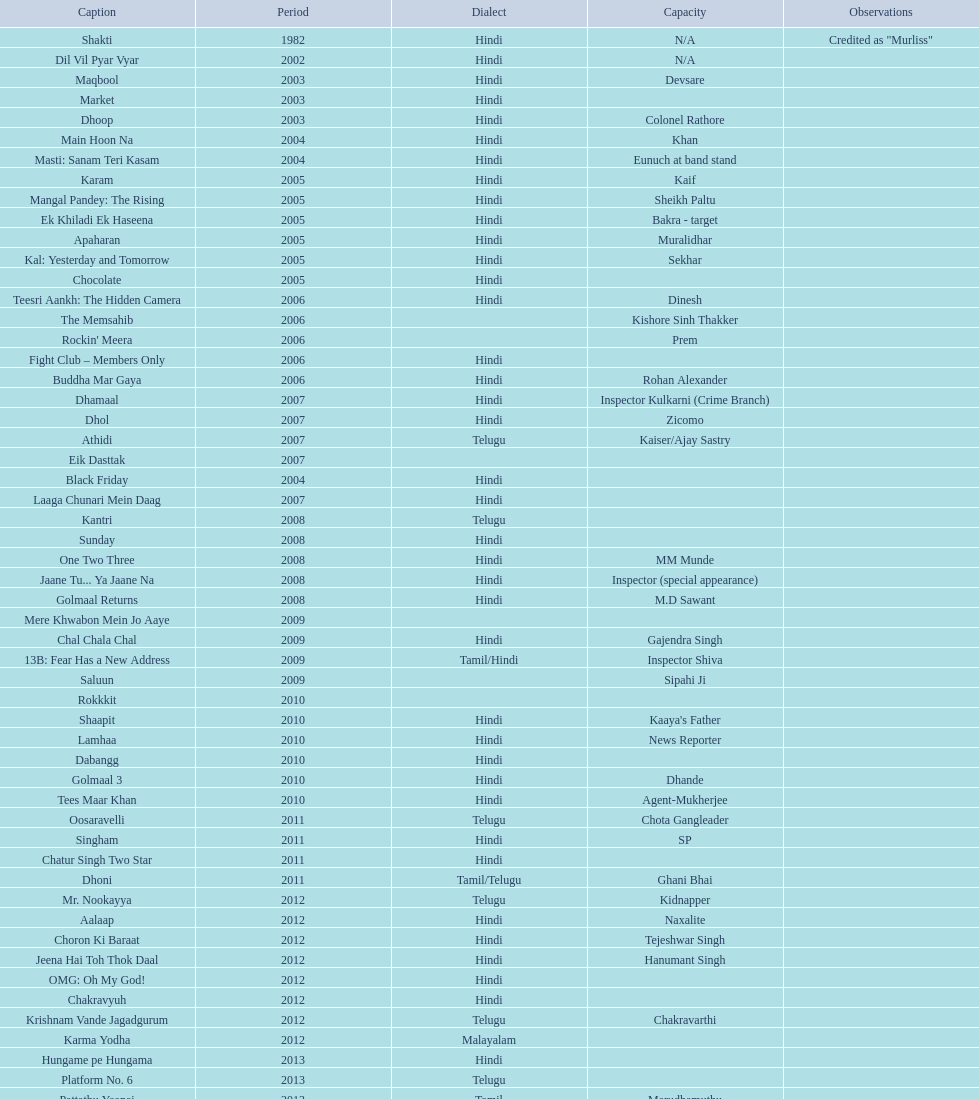Could you parse the entire table as a dict? {'header': ['Caption', 'Period', 'Dialect', 'Capacity', 'Observations'], 'rows': [['Shakti', '1982', 'Hindi', 'N/A', 'Credited as "Murliss"'], ['Dil Vil Pyar Vyar', '2002', 'Hindi', 'N/A', ''], ['Maqbool', '2003', 'Hindi', 'Devsare', ''], ['Market', '2003', 'Hindi', '', ''], ['Dhoop', '2003', 'Hindi', 'Colonel Rathore', ''], ['Main Hoon Na', '2004', 'Hindi', 'Khan', ''], ['Masti: Sanam Teri Kasam', '2004', 'Hindi', 'Eunuch at band stand', ''], ['Karam', '2005', 'Hindi', 'Kaif', ''], ['Mangal Pandey: The Rising', '2005', 'Hindi', 'Sheikh Paltu', ''], ['Ek Khiladi Ek Haseena', '2005', 'Hindi', 'Bakra - target', ''], ['Apaharan', '2005', 'Hindi', 'Muralidhar', ''], ['Kal: Yesterday and Tomorrow', '2005', 'Hindi', 'Sekhar', ''], ['Chocolate', '2005', 'Hindi', '', ''], ['Teesri Aankh: The Hidden Camera', '2006', 'Hindi', 'Dinesh', ''], ['The Memsahib', '2006', '', 'Kishore Sinh Thakker', ''], ["Rockin' Meera", '2006', '', 'Prem', ''], ['Fight Club – Members Only', '2006', 'Hindi', '', ''], ['Buddha Mar Gaya', '2006', 'Hindi', 'Rohan Alexander', ''], ['Dhamaal', '2007', 'Hindi', 'Inspector Kulkarni (Crime Branch)', ''], ['Dhol', '2007', 'Hindi', 'Zicomo', ''], ['Athidi', '2007', 'Telugu', 'Kaiser/Ajay Sastry', ''], ['Eik Dasttak', '2007', '', '', ''], ['Black Friday', '2004', 'Hindi', '', ''], ['Laaga Chunari Mein Daag', '2007', 'Hindi', '', ''], ['Kantri', '2008', 'Telugu', '', ''], ['Sunday', '2008', 'Hindi', '', ''], ['One Two Three', '2008', 'Hindi', 'MM Munde', ''], ['Jaane Tu... Ya Jaane Na', '2008', 'Hindi', 'Inspector (special appearance)', ''], ['Golmaal Returns', '2008', 'Hindi', 'M.D Sawant', ''], ['Mere Khwabon Mein Jo Aaye', '2009', '', '', ''], ['Chal Chala Chal', '2009', 'Hindi', 'Gajendra Singh', ''], ['13B: Fear Has a New Address', '2009', 'Tamil/Hindi', 'Inspector Shiva', ''], ['Saluun', '2009', '', 'Sipahi Ji', ''], ['Rokkkit', '2010', '', '', ''], ['Shaapit', '2010', 'Hindi', "Kaaya's Father", ''], ['Lamhaa', '2010', 'Hindi', 'News Reporter', ''], ['Dabangg', '2010', 'Hindi', '', ''], ['Golmaal 3', '2010', 'Hindi', 'Dhande', ''], ['Tees Maar Khan', '2010', 'Hindi', 'Agent-Mukherjee', ''], ['Oosaravelli', '2011', 'Telugu', 'Chota Gangleader', ''], ['Singham', '2011', 'Hindi', 'SP', ''], ['Chatur Singh Two Star', '2011', 'Hindi', '', ''], ['Dhoni', '2011', 'Tamil/Telugu', 'Ghani Bhai', ''], ['Mr. Nookayya', '2012', 'Telugu', 'Kidnapper', ''], ['Aalaap', '2012', 'Hindi', 'Naxalite', ''], ['Choron Ki Baraat', '2012', 'Hindi', 'Tejeshwar Singh', ''], ['Jeena Hai Toh Thok Daal', '2012', 'Hindi', 'Hanumant Singh', ''], ['OMG: Oh My God!', '2012', 'Hindi', '', ''], ['Chakravyuh', '2012', 'Hindi', '', ''], ['Krishnam Vande Jagadgurum', '2012', 'Telugu', 'Chakravarthi', ''], ['Karma Yodha', '2012', 'Malayalam', '', ''], ['Hungame pe Hungama', '2013', 'Hindi', '', ''], ['Platform No. 6', '2013', 'Telugu', '', ''], ['Pattathu Yaanai', '2013', 'Tamil', 'Marudhamuthu', ''], ['Zindagi 50-50', '2013', 'Hindi', '', ''], ['Yevadu', '2013', 'Telugu', 'Durani', ''], ['Karmachari', '2013', 'Telugu', '', '']]} What title is before dhol in 2007? Dhamaal. 